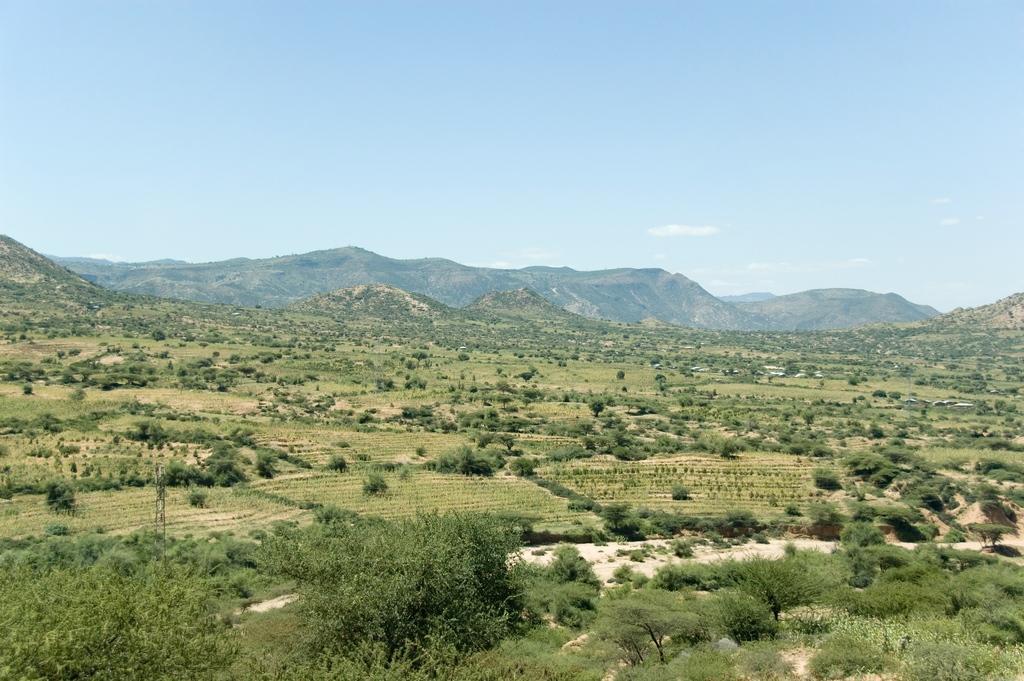Could you give a brief overview of what you see in this image? There is an open land with some trees, plants and some grass on it. In the background we can observe some hills and above the hill there is sky with some clouds. 